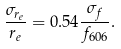<formula> <loc_0><loc_0><loc_500><loc_500>\frac { \sigma _ { r _ { e } } } { r _ { e } } = 0 . 5 4 \frac { \sigma _ { f } } { f _ { 6 0 6 } } .</formula> 